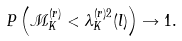Convert formula to latex. <formula><loc_0><loc_0><loc_500><loc_500>P \left ( { \mathcal { M } } _ { K } ^ { ( r ) } < \lambda _ { K } ^ { ( r ) 2 } ( l ) \right ) \rightarrow 1 .</formula> 